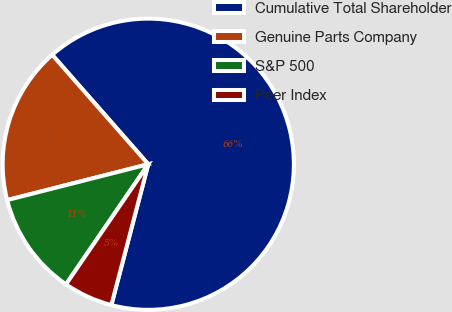Convert chart to OTSL. <chart><loc_0><loc_0><loc_500><loc_500><pie_chart><fcel>Cumulative Total Shareholder<fcel>Genuine Parts Company<fcel>S&P 500<fcel>Peer Index<nl><fcel>65.55%<fcel>17.49%<fcel>11.48%<fcel>5.48%<nl></chart> 